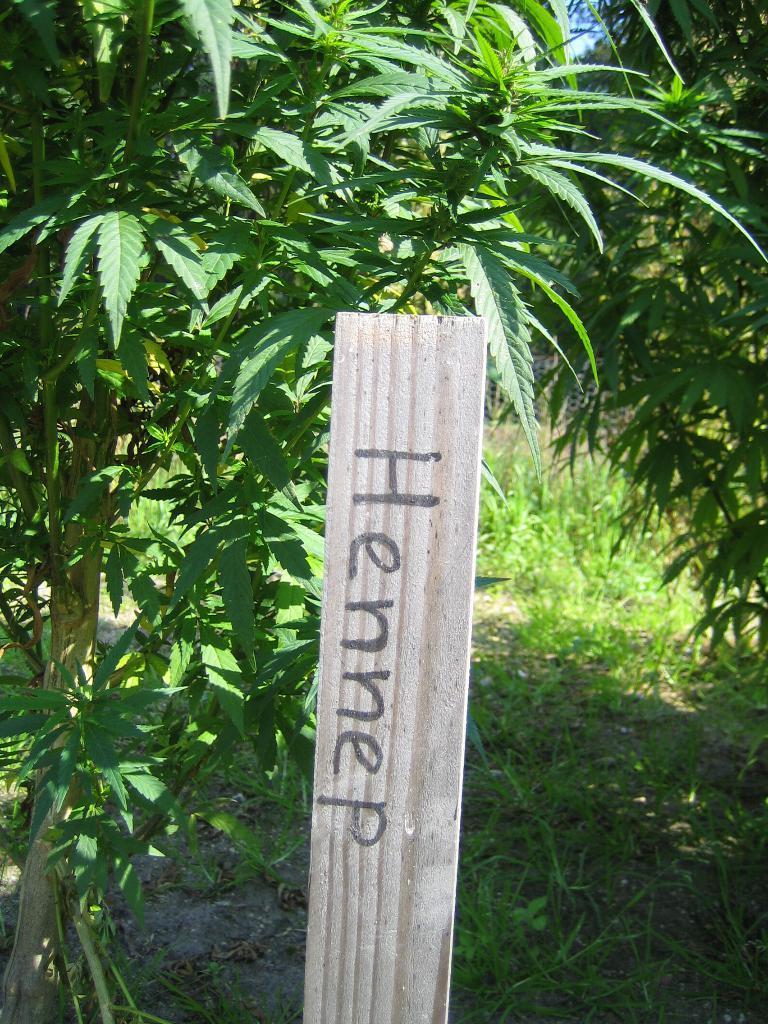Please provide a concise description of this image. In front of the picture, we see a pole or a board with text written as "HENNEP". At the bottom, we see the grass. There are trees in the background. 